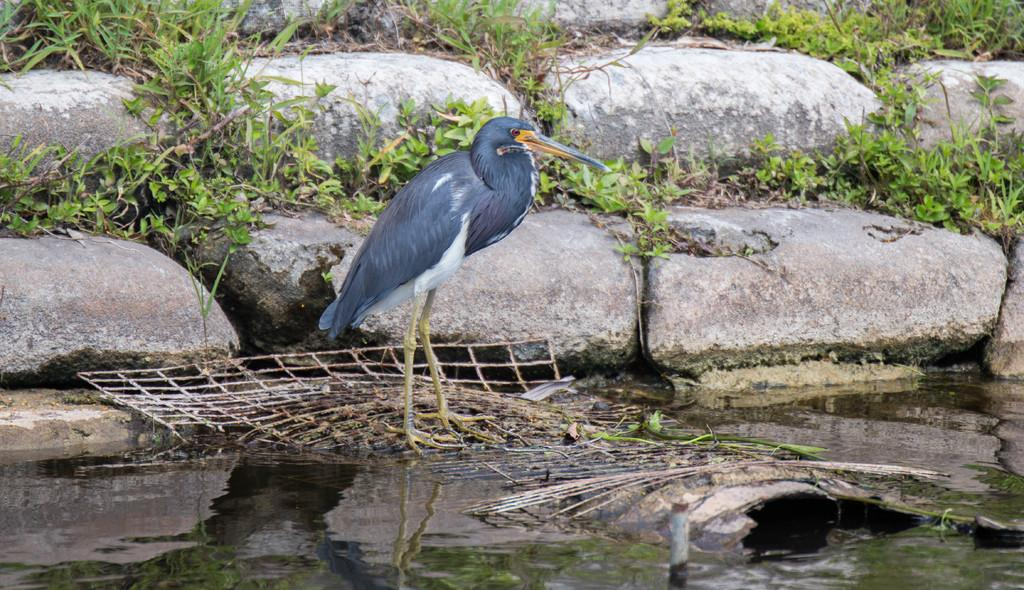What is the primary element visible in the image? There is water in the image. What type of animal can be seen in the image? There is a bird in the image. What type of vegetation is present in the image? There is grass in the image. What type of geological formation is present in the image? There are rocks in the image. What type of pie is being served at the harbor in the image? There is no pie or harbor present in the image; it features water, a bird, grass, and rocks. 